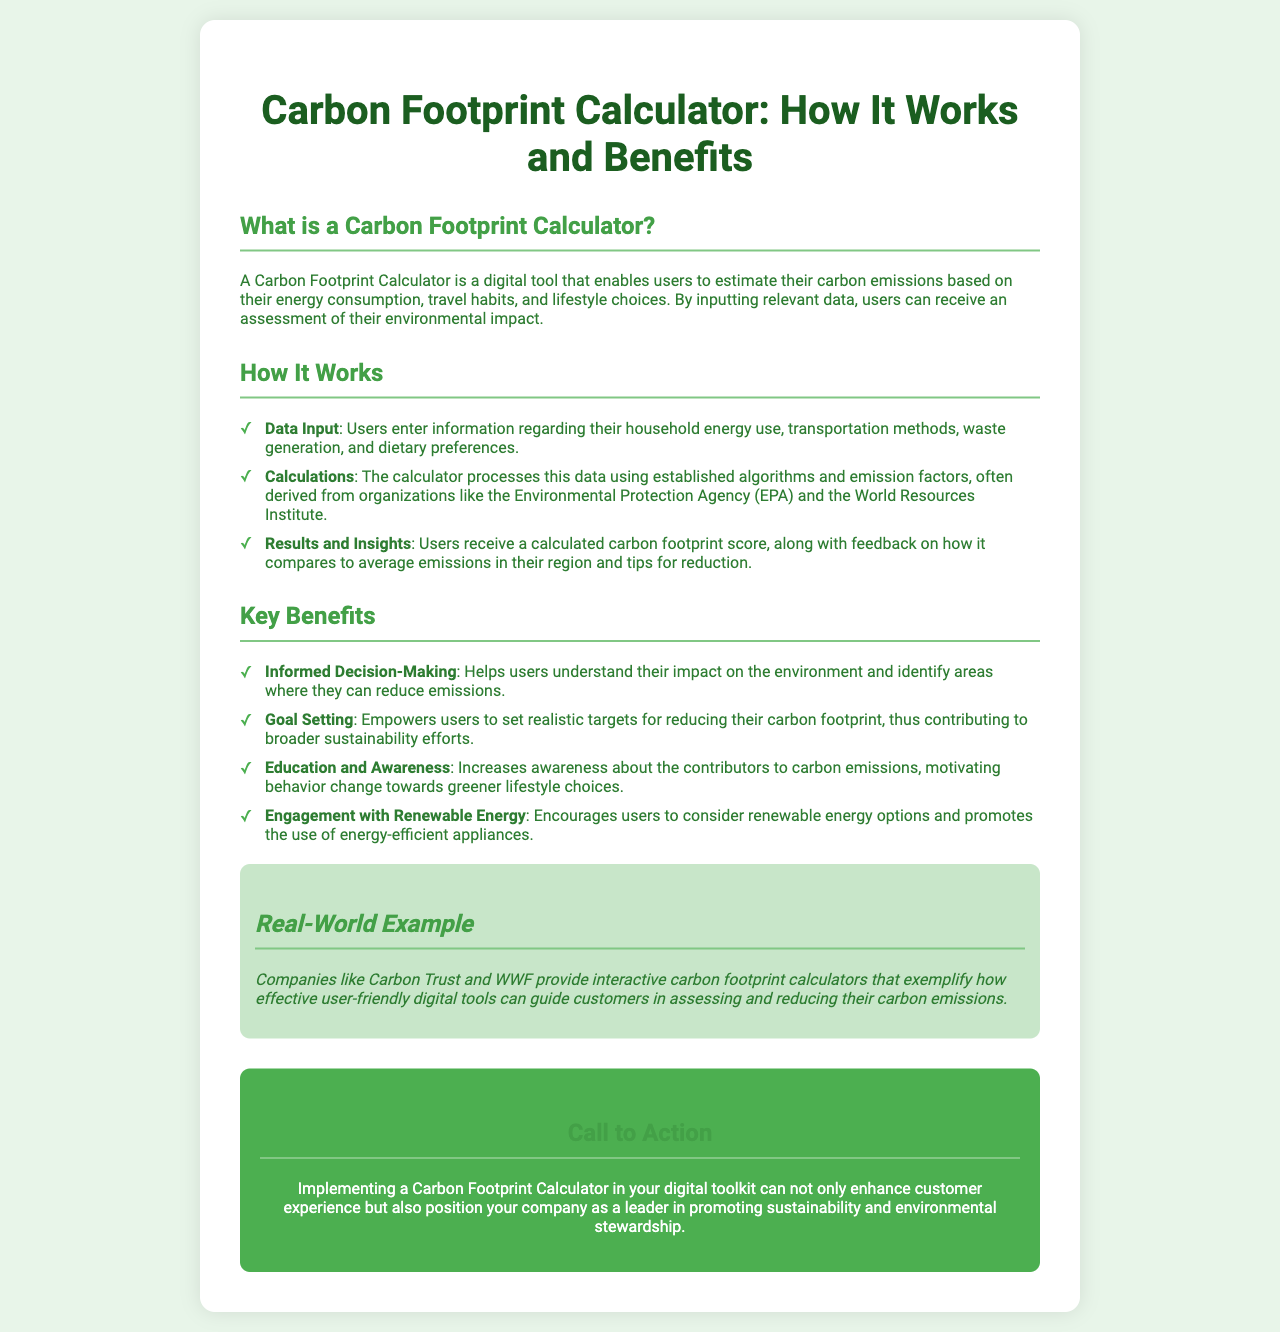What is a Carbon Footprint Calculator? The document defines it as a digital tool that enables users to estimate their carbon emissions based on energy consumption, travel habits, and lifestyle choices.
Answer: A digital tool How does the Carbon Footprint Calculator process data? The document states that it processes data using established algorithms and emission factors, often derived from organizations like the EPA and the World Resources Institute.
Answer: Established algorithms What are the key benefits of using the calculator? The document lists several benefits, including informed decision-making, goal setting, education and awareness, and engagement with renewable energy.
Answer: Informed decision-making What additional information does the calculator provide to users? The document mentions that users receive a calculated carbon footprint score, along with feedback on how it compares to average emissions in their region and tips for reduction.
Answer: A calculated carbon footprint score Which organizations provide interactive carbon footprint calculators as examples? The document lists Carbon Trust and WWF as examples of organizations that provide interactive calculators.
Answer: Carbon Trust and WWF 